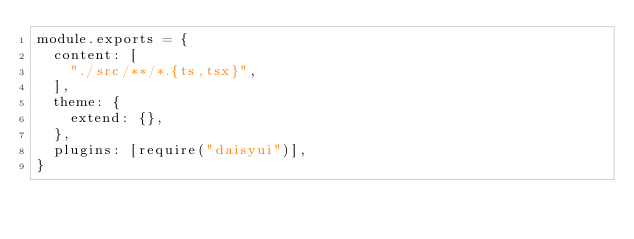Convert code to text. <code><loc_0><loc_0><loc_500><loc_500><_JavaScript_>module.exports = {
  content: [
    "./src/**/*.{ts,tsx}",
  ],
  theme: {
    extend: {},
  },
  plugins: [require("daisyui")],
}
</code> 